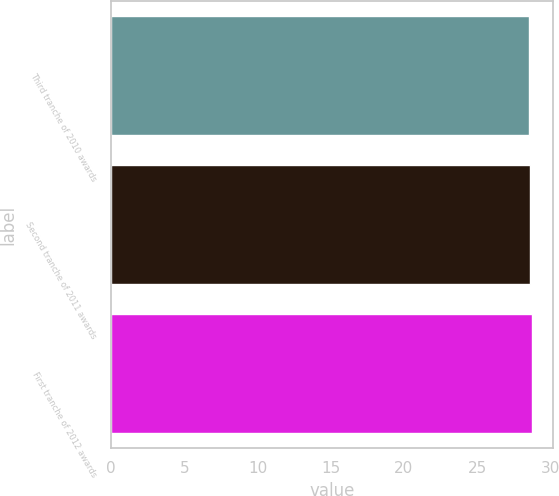Convert chart. <chart><loc_0><loc_0><loc_500><loc_500><bar_chart><fcel>Third tranche of 2010 awards<fcel>Second tranche of 2011 awards<fcel>First tranche of 2012 awards<nl><fcel>28.53<fcel>28.63<fcel>28.73<nl></chart> 